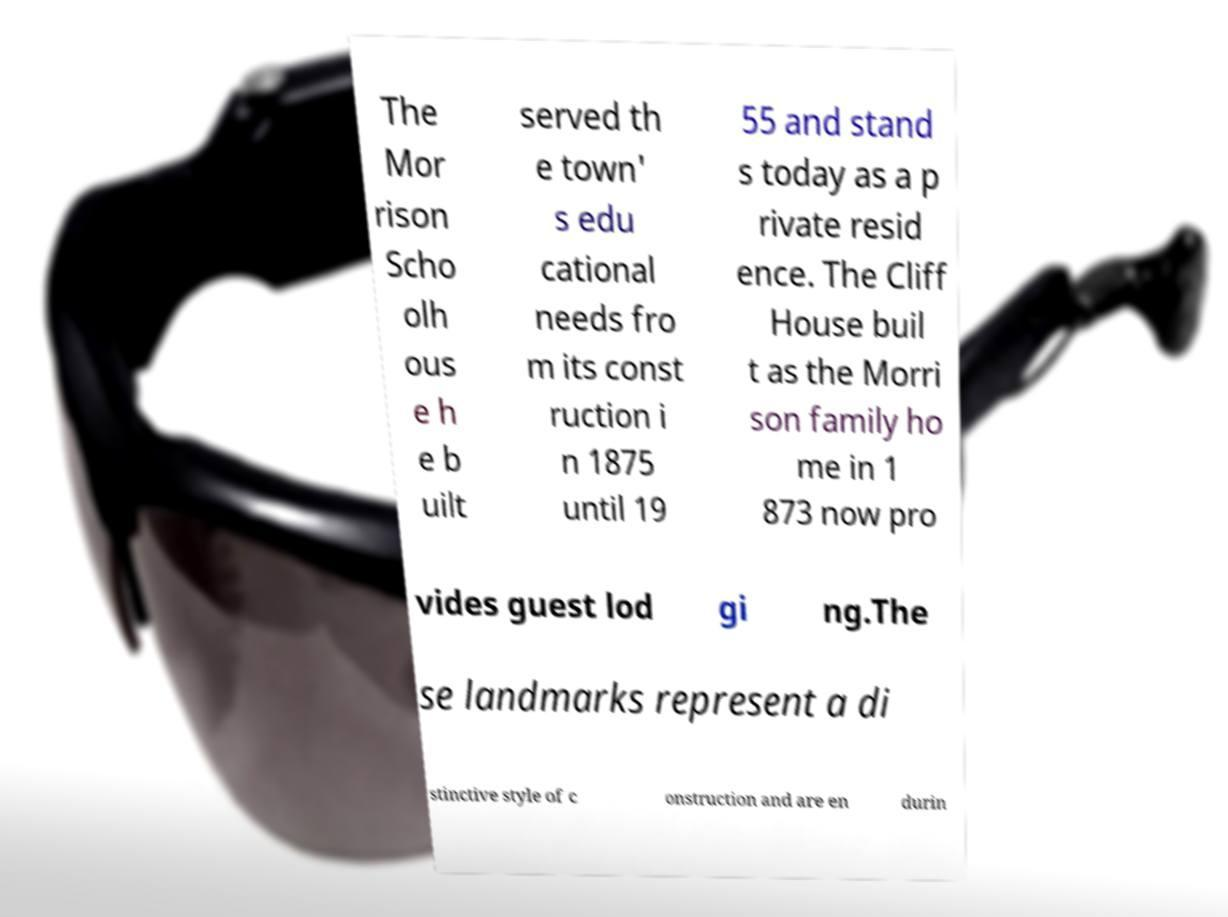I need the written content from this picture converted into text. Can you do that? The Mor rison Scho olh ous e h e b uilt served th e town' s edu cational needs fro m its const ruction i n 1875 until 19 55 and stand s today as a p rivate resid ence. The Cliff House buil t as the Morri son family ho me in 1 873 now pro vides guest lod gi ng.The se landmarks represent a di stinctive style of c onstruction and are en durin 